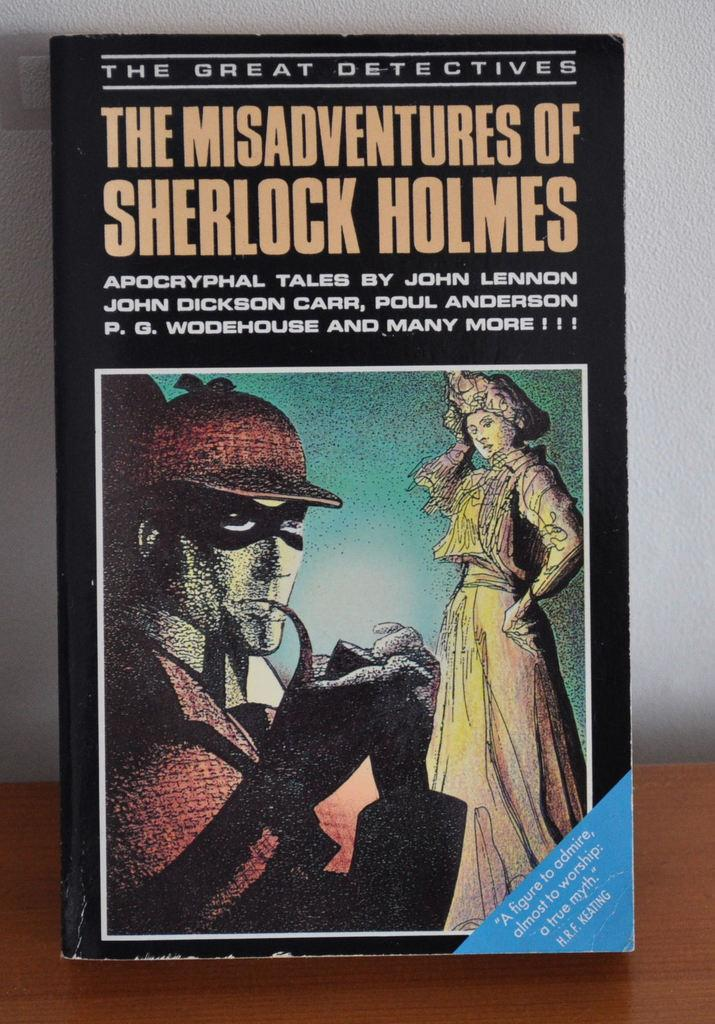<image>
Provide a brief description of the given image. H.R.F. Keating said The Misadventures of Sherlock Holmes was "A figure to admire, almost to worship." 